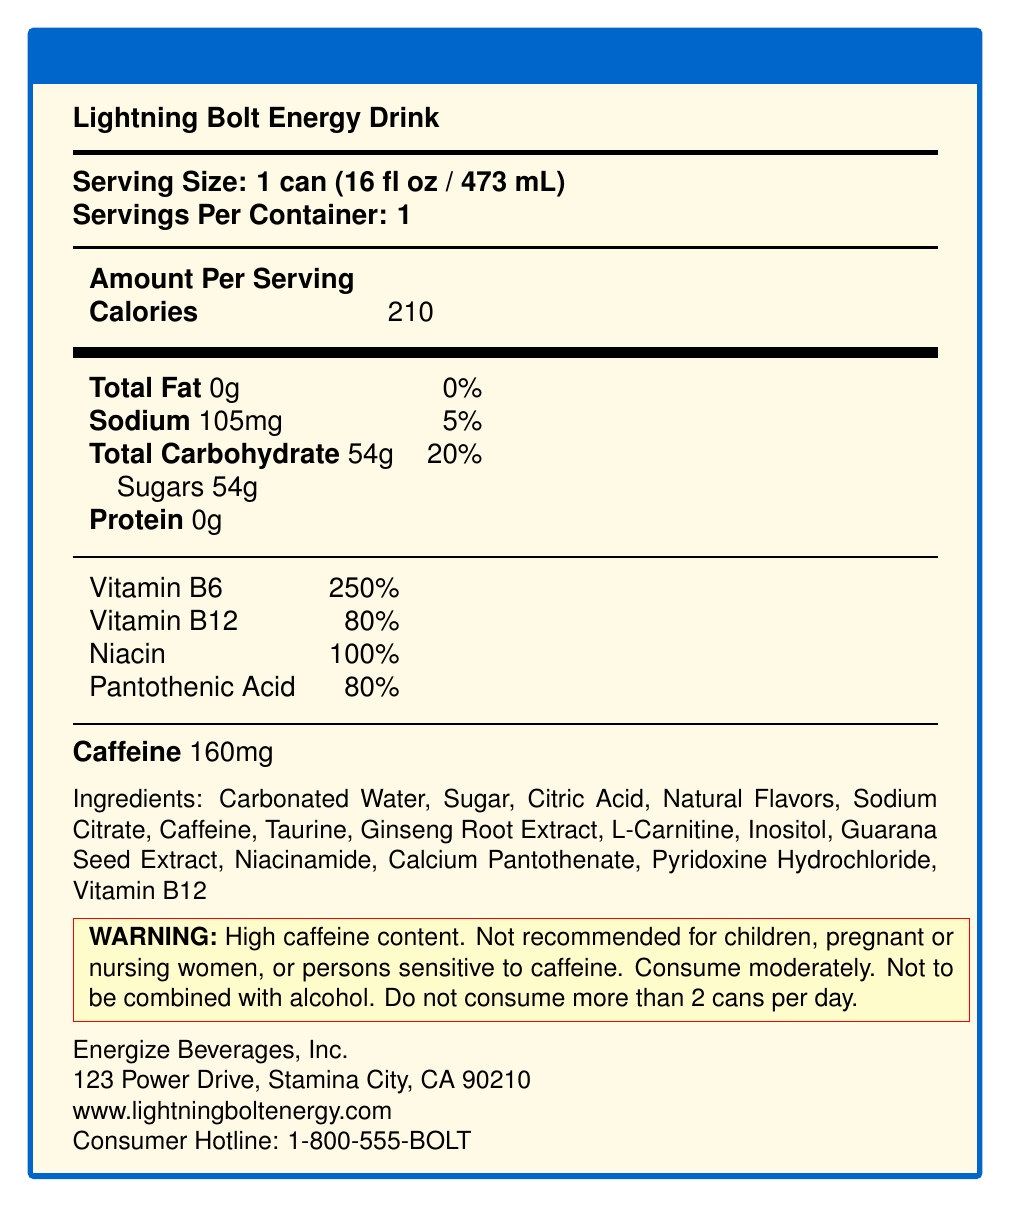what is the serving size? The document states that the serving size for Lightning Bolt Energy Drink is 1 can, which is equivalent to 16 fluid ounces (473 milliliters).
Answer: 1 can (16 fl oz / 473 mL) how many calories are in one serving of this energy drink? The document specifies that one serving of the Lightning Bolt Energy Drink contains 210 calories.
Answer: 210 calories what is the total carbohydrate content per serving? The document indicates that the total carbohydrate content per serving is 54 grams.
Answer: 54g which vitamins are included in this energy drink? The document lists the included vitamins along with their respective daily values: Vitamin B6 (250% DV), Vitamin B12 (80% DV), Niacin (100% DV), and Pantothenic Acid (80% DV).
Answer: Vitamin B6, Vitamin B12, Niacin, Pantothenic Acid what is the caffeine content per can? According to the document, each can of Lightning Bolt Energy Drink contains 160 milligrams of caffeine.
Answer: 160mg what is the company's consumer hotline number? The document provides the consumer hotline number of Energize Beverages, Inc. as 1-800-555-BOLT.
Answer: 1-800-555-BOLT what are the main ingredients in this energy drink? A. Carbonated Water, Sugar, Citric Acid, Natural Flavors B. Taurine, Ginseng Root Extract, Inositol, Guarana Seed Extract C. All of the above The document lists all the ingredients, including carbonated water, sugar, citric acid, natural flavors, caffeine, taurine, ginseng root extract, and more, indicating that all options (A and B) are correct.
Answer: C. All of the above which of the following is not recommended for children? A. Caffeine content B. Pantothenic Acid content C. Natural flavors The document includes a warning label stating "High caffeine content. Not recommended for children," thus the correct answer is A.
Answer: A. Caffeine content is this energy drink suitable for pregnant or nursing women? The warning label explicitly states that it is not recommended for pregnant or nursing women.
Answer: No describe the main purpose of this Nutrition Facts Label document. The document serves to inform consumers about the nutritional composition and safety concerns of the energy drink while providing company contact details and marketing information.
Answer: The Nutrition Facts Label document for Lightning Bolt Energy Drink provides detailed information about the product's serving size, calorie count, nutrient content, ingredient list, caffeine content, and warnings. It includes company information, marketing claims, and additional regulatory and environmental details. how much protein is included in one serving of this energy drink? The document specifies that there is no protein in one serving of the drink.
Answer: 0g how many servings are there per container? The document states that there is one serving per container.
Answer: 1 what percentage of the daily value for sodium does one serving contain? The document indicates that one serving contains 105mg of sodium, which is 5% of the daily value.
Answer: 5% what is the main target audience for this energy drink? The document specifies that the target audience for this energy drink is active adults aged 18-35.
Answer: Active adults aged 18-35 what are the marketing claims for this energy drink? The document lists the marketing claims which include boosting energy and mental focus, enhancing physical performance, being fat-free, and being packed with B-vitamins.
Answer: Boosts energy and mental focus, Enhances physical performance, Zero fat, Packed with B-vitamins is this product FDA approved? The document indicates that the product is FDA approved under regulatory compliance.
Answer: Yes what is the carbon footprint of this energy drink? The document mentions that the company is working towards carbon neutrality by 2025, but it does not provide specific details about the current carbon footprint.
Answer: Not enough information 